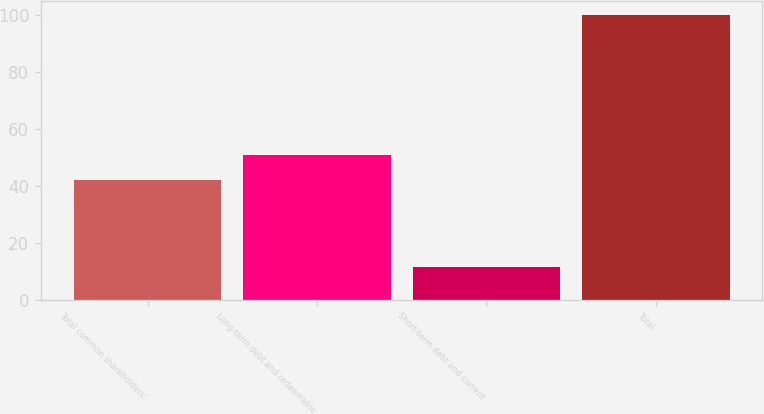Convert chart to OTSL. <chart><loc_0><loc_0><loc_500><loc_500><bar_chart><fcel>Total common shareholders'<fcel>Long-term debt and redeemable<fcel>Short-term debt and current<fcel>Total<nl><fcel>42.1<fcel>50.95<fcel>11.5<fcel>100<nl></chart> 